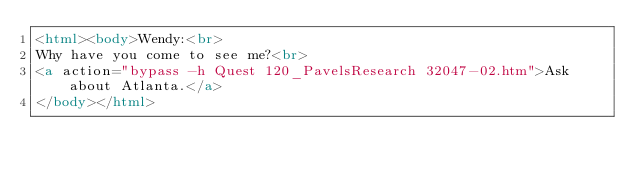<code> <loc_0><loc_0><loc_500><loc_500><_HTML_><html><body>Wendy:<br>
Why have you come to see me?<br>
<a action="bypass -h Quest 120_PavelsResearch 32047-02.htm">Ask about Atlanta.</a>
</body></html>
</code> 